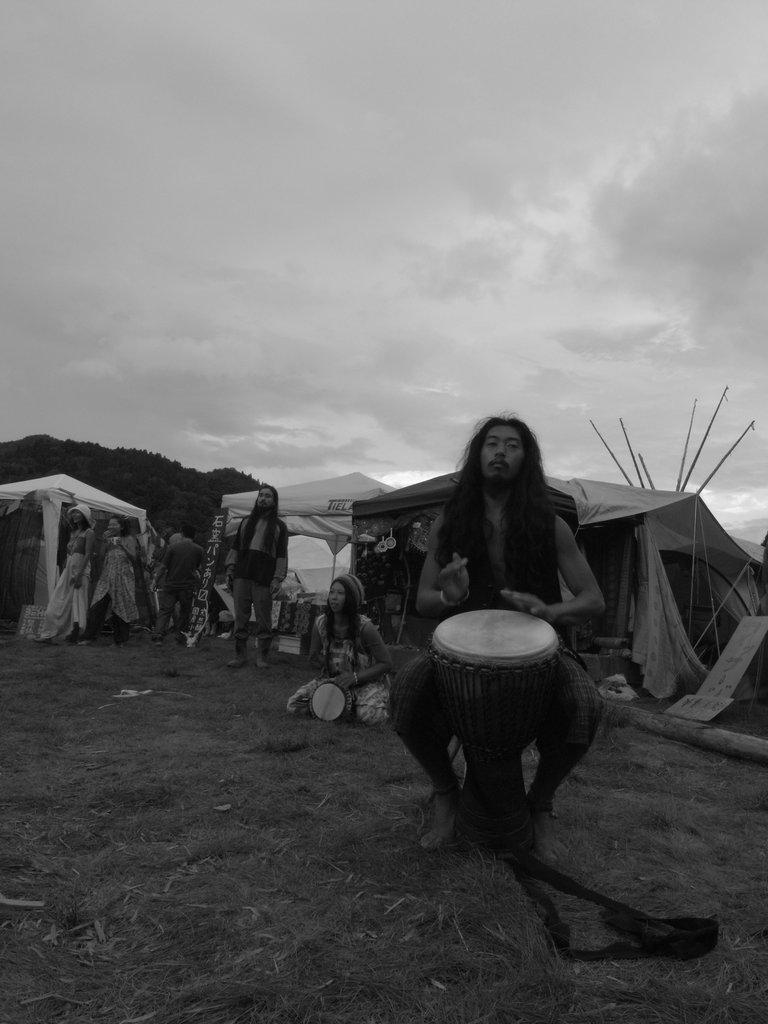How many people are in the image? There are people in the image, but the exact number is not specified. What can be seen in the background of the image? In the background of the image, there are tents, a tree, and the sky. What is a person doing on the right side of the image? A person is sitting and playing a drum on the right side of the image. What caption is written on the drum in the image? There is no caption written on the drum in the image. How many lines can be seen on the tree in the image? The facts do not mention any lines on the tree in the image. Can you spot a frog in the image? There is no mention of a frog in the image. 